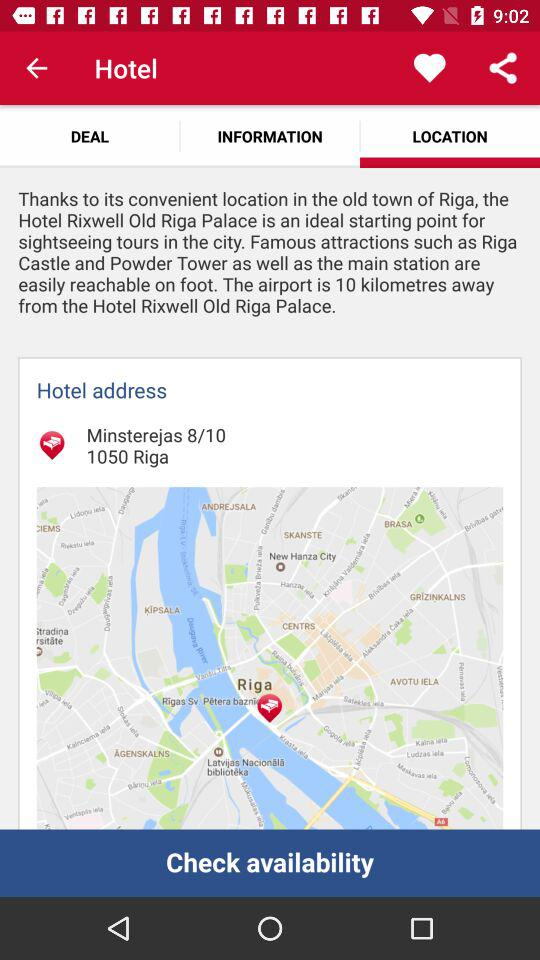Which tab has been selected? The tab "LOCATION" has been selected. 